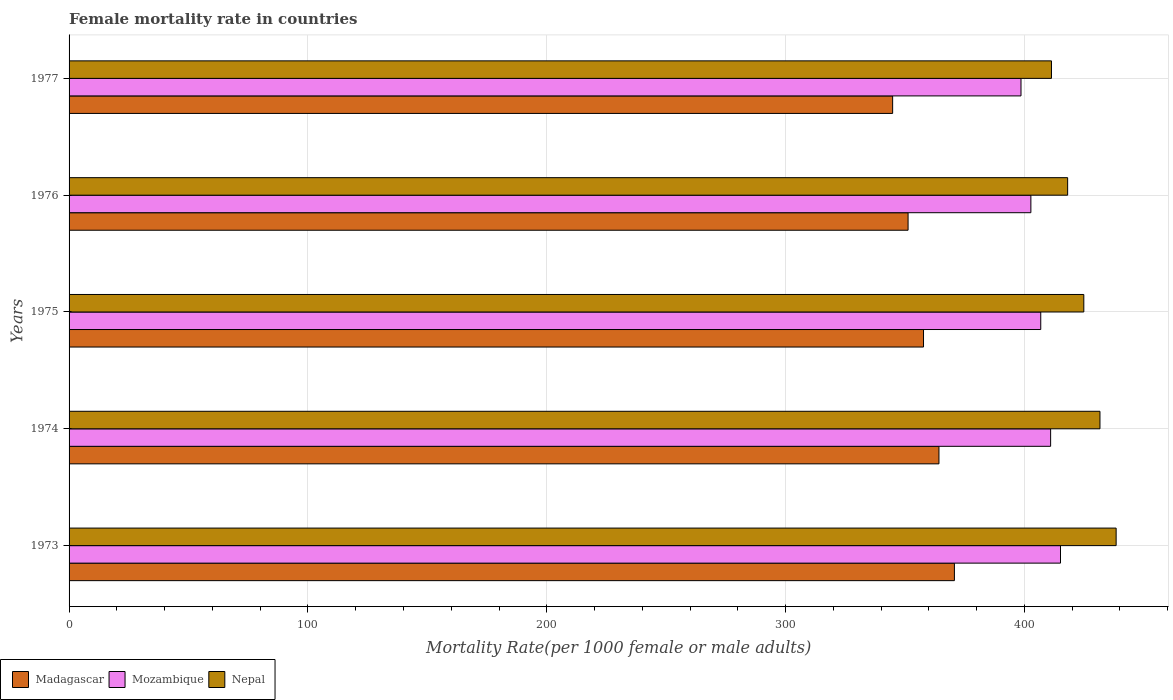How many different coloured bars are there?
Offer a terse response. 3. How many groups of bars are there?
Provide a short and direct response. 5. How many bars are there on the 3rd tick from the bottom?
Give a very brief answer. 3. What is the label of the 3rd group of bars from the top?
Give a very brief answer. 1975. What is the female mortality rate in Nepal in 1975?
Provide a succinct answer. 424.85. Across all years, what is the maximum female mortality rate in Madagascar?
Provide a succinct answer. 370.67. Across all years, what is the minimum female mortality rate in Madagascar?
Give a very brief answer. 344.81. In which year was the female mortality rate in Nepal maximum?
Your response must be concise. 1973. What is the total female mortality rate in Nepal in the graph?
Make the answer very short. 2124.25. What is the difference between the female mortality rate in Mozambique in 1975 and that in 1977?
Ensure brevity in your answer.  8.27. What is the difference between the female mortality rate in Mozambique in 1976 and the female mortality rate in Nepal in 1974?
Your answer should be very brief. -28.93. What is the average female mortality rate in Nepal per year?
Provide a short and direct response. 424.85. In the year 1976, what is the difference between the female mortality rate in Nepal and female mortality rate in Mozambique?
Your answer should be compact. 15.39. What is the ratio of the female mortality rate in Madagascar in 1975 to that in 1977?
Give a very brief answer. 1.04. Is the difference between the female mortality rate in Nepal in 1975 and 1976 greater than the difference between the female mortality rate in Mozambique in 1975 and 1976?
Give a very brief answer. Yes. What is the difference between the highest and the second highest female mortality rate in Nepal?
Offer a very short reply. 6.77. What is the difference between the highest and the lowest female mortality rate in Mozambique?
Your answer should be compact. 16.53. In how many years, is the female mortality rate in Madagascar greater than the average female mortality rate in Madagascar taken over all years?
Keep it short and to the point. 2. What does the 2nd bar from the top in 1977 represents?
Ensure brevity in your answer.  Mozambique. What does the 3rd bar from the bottom in 1973 represents?
Ensure brevity in your answer.  Nepal. Are all the bars in the graph horizontal?
Give a very brief answer. Yes. How many years are there in the graph?
Provide a succinct answer. 5. Does the graph contain any zero values?
Offer a terse response. No. Does the graph contain grids?
Make the answer very short. Yes. How are the legend labels stacked?
Give a very brief answer. Horizontal. What is the title of the graph?
Ensure brevity in your answer.  Female mortality rate in countries. What is the label or title of the X-axis?
Your response must be concise. Mortality Rate(per 1000 female or male adults). What is the label or title of the Y-axis?
Your answer should be compact. Years. What is the Mortality Rate(per 1000 female or male adults) in Madagascar in 1973?
Make the answer very short. 370.67. What is the Mortality Rate(per 1000 female or male adults) of Mozambique in 1973?
Provide a succinct answer. 415.09. What is the Mortality Rate(per 1000 female or male adults) in Nepal in 1973?
Ensure brevity in your answer.  438.39. What is the Mortality Rate(per 1000 female or male adults) of Madagascar in 1974?
Your response must be concise. 364.21. What is the Mortality Rate(per 1000 female or male adults) of Mozambique in 1974?
Your answer should be very brief. 410.96. What is the Mortality Rate(per 1000 female or male adults) of Nepal in 1974?
Offer a terse response. 431.62. What is the Mortality Rate(per 1000 female or male adults) in Madagascar in 1975?
Keep it short and to the point. 357.74. What is the Mortality Rate(per 1000 female or male adults) in Mozambique in 1975?
Offer a very short reply. 406.82. What is the Mortality Rate(per 1000 female or male adults) of Nepal in 1975?
Your answer should be compact. 424.85. What is the Mortality Rate(per 1000 female or male adults) in Madagascar in 1976?
Ensure brevity in your answer.  351.28. What is the Mortality Rate(per 1000 female or male adults) of Mozambique in 1976?
Offer a terse response. 402.69. What is the Mortality Rate(per 1000 female or male adults) in Nepal in 1976?
Your response must be concise. 418.08. What is the Mortality Rate(per 1000 female or male adults) of Madagascar in 1977?
Your answer should be compact. 344.81. What is the Mortality Rate(per 1000 female or male adults) of Mozambique in 1977?
Provide a short and direct response. 398.56. What is the Mortality Rate(per 1000 female or male adults) in Nepal in 1977?
Ensure brevity in your answer.  411.31. Across all years, what is the maximum Mortality Rate(per 1000 female or male adults) of Madagascar?
Your response must be concise. 370.67. Across all years, what is the maximum Mortality Rate(per 1000 female or male adults) of Mozambique?
Give a very brief answer. 415.09. Across all years, what is the maximum Mortality Rate(per 1000 female or male adults) of Nepal?
Give a very brief answer. 438.39. Across all years, what is the minimum Mortality Rate(per 1000 female or male adults) of Madagascar?
Your answer should be compact. 344.81. Across all years, what is the minimum Mortality Rate(per 1000 female or male adults) of Mozambique?
Your response must be concise. 398.56. Across all years, what is the minimum Mortality Rate(per 1000 female or male adults) of Nepal?
Your response must be concise. 411.31. What is the total Mortality Rate(per 1000 female or male adults) in Madagascar in the graph?
Keep it short and to the point. 1788.71. What is the total Mortality Rate(per 1000 female or male adults) in Mozambique in the graph?
Your response must be concise. 2034.12. What is the total Mortality Rate(per 1000 female or male adults) of Nepal in the graph?
Provide a succinct answer. 2124.25. What is the difference between the Mortality Rate(per 1000 female or male adults) of Madagascar in 1973 and that in 1974?
Ensure brevity in your answer.  6.46. What is the difference between the Mortality Rate(per 1000 female or male adults) in Mozambique in 1973 and that in 1974?
Your answer should be very brief. 4.13. What is the difference between the Mortality Rate(per 1000 female or male adults) in Nepal in 1973 and that in 1974?
Your answer should be compact. 6.77. What is the difference between the Mortality Rate(per 1000 female or male adults) in Madagascar in 1973 and that in 1975?
Offer a terse response. 12.93. What is the difference between the Mortality Rate(per 1000 female or male adults) in Mozambique in 1973 and that in 1975?
Keep it short and to the point. 8.27. What is the difference between the Mortality Rate(per 1000 female or male adults) of Nepal in 1973 and that in 1975?
Your answer should be compact. 13.54. What is the difference between the Mortality Rate(per 1000 female or male adults) of Madagascar in 1973 and that in 1976?
Give a very brief answer. 19.39. What is the difference between the Mortality Rate(per 1000 female or male adults) of Mozambique in 1973 and that in 1976?
Ensure brevity in your answer.  12.4. What is the difference between the Mortality Rate(per 1000 female or male adults) of Nepal in 1973 and that in 1976?
Offer a terse response. 20.3. What is the difference between the Mortality Rate(per 1000 female or male adults) in Madagascar in 1973 and that in 1977?
Your answer should be very brief. 25.86. What is the difference between the Mortality Rate(per 1000 female or male adults) of Mozambique in 1973 and that in 1977?
Make the answer very short. 16.53. What is the difference between the Mortality Rate(per 1000 female or male adults) of Nepal in 1973 and that in 1977?
Offer a terse response. 27.07. What is the difference between the Mortality Rate(per 1000 female or male adults) of Madagascar in 1974 and that in 1975?
Keep it short and to the point. 6.46. What is the difference between the Mortality Rate(per 1000 female or male adults) of Mozambique in 1974 and that in 1975?
Provide a succinct answer. 4.13. What is the difference between the Mortality Rate(per 1000 female or male adults) of Nepal in 1974 and that in 1975?
Your answer should be compact. 6.77. What is the difference between the Mortality Rate(per 1000 female or male adults) in Madagascar in 1974 and that in 1976?
Your answer should be compact. 12.93. What is the difference between the Mortality Rate(per 1000 female or male adults) in Mozambique in 1974 and that in 1976?
Make the answer very short. 8.27. What is the difference between the Mortality Rate(per 1000 female or male adults) of Nepal in 1974 and that in 1976?
Offer a very short reply. 13.54. What is the difference between the Mortality Rate(per 1000 female or male adults) in Madagascar in 1974 and that in 1977?
Make the answer very short. 19.39. What is the difference between the Mortality Rate(per 1000 female or male adults) of Mozambique in 1974 and that in 1977?
Your response must be concise. 12.4. What is the difference between the Mortality Rate(per 1000 female or male adults) of Nepal in 1974 and that in 1977?
Your answer should be compact. 20.3. What is the difference between the Mortality Rate(per 1000 female or male adults) of Madagascar in 1975 and that in 1976?
Provide a short and direct response. 6.46. What is the difference between the Mortality Rate(per 1000 female or male adults) in Mozambique in 1975 and that in 1976?
Make the answer very short. 4.13. What is the difference between the Mortality Rate(per 1000 female or male adults) in Nepal in 1975 and that in 1976?
Your response must be concise. 6.77. What is the difference between the Mortality Rate(per 1000 female or male adults) in Madagascar in 1975 and that in 1977?
Ensure brevity in your answer.  12.93. What is the difference between the Mortality Rate(per 1000 female or male adults) of Mozambique in 1975 and that in 1977?
Keep it short and to the point. 8.27. What is the difference between the Mortality Rate(per 1000 female or male adults) of Nepal in 1975 and that in 1977?
Keep it short and to the point. 13.54. What is the difference between the Mortality Rate(per 1000 female or male adults) in Madagascar in 1976 and that in 1977?
Give a very brief answer. 6.46. What is the difference between the Mortality Rate(per 1000 female or male adults) in Mozambique in 1976 and that in 1977?
Ensure brevity in your answer.  4.13. What is the difference between the Mortality Rate(per 1000 female or male adults) of Nepal in 1976 and that in 1977?
Your answer should be compact. 6.77. What is the difference between the Mortality Rate(per 1000 female or male adults) of Madagascar in 1973 and the Mortality Rate(per 1000 female or male adults) of Mozambique in 1974?
Your answer should be compact. -40.29. What is the difference between the Mortality Rate(per 1000 female or male adults) of Madagascar in 1973 and the Mortality Rate(per 1000 female or male adults) of Nepal in 1974?
Keep it short and to the point. -60.95. What is the difference between the Mortality Rate(per 1000 female or male adults) in Mozambique in 1973 and the Mortality Rate(per 1000 female or male adults) in Nepal in 1974?
Offer a terse response. -16.53. What is the difference between the Mortality Rate(per 1000 female or male adults) of Madagascar in 1973 and the Mortality Rate(per 1000 female or male adults) of Mozambique in 1975?
Ensure brevity in your answer.  -36.15. What is the difference between the Mortality Rate(per 1000 female or male adults) in Madagascar in 1973 and the Mortality Rate(per 1000 female or male adults) in Nepal in 1975?
Your response must be concise. -54.18. What is the difference between the Mortality Rate(per 1000 female or male adults) in Mozambique in 1973 and the Mortality Rate(per 1000 female or male adults) in Nepal in 1975?
Your response must be concise. -9.76. What is the difference between the Mortality Rate(per 1000 female or male adults) of Madagascar in 1973 and the Mortality Rate(per 1000 female or male adults) of Mozambique in 1976?
Provide a succinct answer. -32.02. What is the difference between the Mortality Rate(per 1000 female or male adults) of Madagascar in 1973 and the Mortality Rate(per 1000 female or male adults) of Nepal in 1976?
Keep it short and to the point. -47.41. What is the difference between the Mortality Rate(per 1000 female or male adults) in Mozambique in 1973 and the Mortality Rate(per 1000 female or male adults) in Nepal in 1976?
Provide a succinct answer. -2.99. What is the difference between the Mortality Rate(per 1000 female or male adults) in Madagascar in 1973 and the Mortality Rate(per 1000 female or male adults) in Mozambique in 1977?
Offer a very short reply. -27.89. What is the difference between the Mortality Rate(per 1000 female or male adults) in Madagascar in 1973 and the Mortality Rate(per 1000 female or male adults) in Nepal in 1977?
Your response must be concise. -40.64. What is the difference between the Mortality Rate(per 1000 female or male adults) in Mozambique in 1973 and the Mortality Rate(per 1000 female or male adults) in Nepal in 1977?
Offer a terse response. 3.78. What is the difference between the Mortality Rate(per 1000 female or male adults) of Madagascar in 1974 and the Mortality Rate(per 1000 female or male adults) of Mozambique in 1975?
Your response must be concise. -42.62. What is the difference between the Mortality Rate(per 1000 female or male adults) in Madagascar in 1974 and the Mortality Rate(per 1000 female or male adults) in Nepal in 1975?
Offer a very short reply. -60.65. What is the difference between the Mortality Rate(per 1000 female or male adults) in Mozambique in 1974 and the Mortality Rate(per 1000 female or male adults) in Nepal in 1975?
Your answer should be very brief. -13.89. What is the difference between the Mortality Rate(per 1000 female or male adults) in Madagascar in 1974 and the Mortality Rate(per 1000 female or male adults) in Mozambique in 1976?
Keep it short and to the point. -38.48. What is the difference between the Mortality Rate(per 1000 female or male adults) of Madagascar in 1974 and the Mortality Rate(per 1000 female or male adults) of Nepal in 1976?
Your answer should be very brief. -53.88. What is the difference between the Mortality Rate(per 1000 female or male adults) in Mozambique in 1974 and the Mortality Rate(per 1000 female or male adults) in Nepal in 1976?
Offer a terse response. -7.12. What is the difference between the Mortality Rate(per 1000 female or male adults) of Madagascar in 1974 and the Mortality Rate(per 1000 female or male adults) of Mozambique in 1977?
Offer a very short reply. -34.35. What is the difference between the Mortality Rate(per 1000 female or male adults) of Madagascar in 1974 and the Mortality Rate(per 1000 female or male adults) of Nepal in 1977?
Offer a terse response. -47.11. What is the difference between the Mortality Rate(per 1000 female or male adults) in Mozambique in 1974 and the Mortality Rate(per 1000 female or male adults) in Nepal in 1977?
Ensure brevity in your answer.  -0.36. What is the difference between the Mortality Rate(per 1000 female or male adults) of Madagascar in 1975 and the Mortality Rate(per 1000 female or male adults) of Mozambique in 1976?
Make the answer very short. -44.95. What is the difference between the Mortality Rate(per 1000 female or male adults) in Madagascar in 1975 and the Mortality Rate(per 1000 female or male adults) in Nepal in 1976?
Ensure brevity in your answer.  -60.34. What is the difference between the Mortality Rate(per 1000 female or male adults) of Mozambique in 1975 and the Mortality Rate(per 1000 female or male adults) of Nepal in 1976?
Offer a terse response. -11.26. What is the difference between the Mortality Rate(per 1000 female or male adults) in Madagascar in 1975 and the Mortality Rate(per 1000 female or male adults) in Mozambique in 1977?
Keep it short and to the point. -40.81. What is the difference between the Mortality Rate(per 1000 female or male adults) in Madagascar in 1975 and the Mortality Rate(per 1000 female or male adults) in Nepal in 1977?
Your answer should be very brief. -53.57. What is the difference between the Mortality Rate(per 1000 female or male adults) of Mozambique in 1975 and the Mortality Rate(per 1000 female or male adults) of Nepal in 1977?
Your answer should be very brief. -4.49. What is the difference between the Mortality Rate(per 1000 female or male adults) in Madagascar in 1976 and the Mortality Rate(per 1000 female or male adults) in Mozambique in 1977?
Make the answer very short. -47.28. What is the difference between the Mortality Rate(per 1000 female or male adults) of Madagascar in 1976 and the Mortality Rate(per 1000 female or male adults) of Nepal in 1977?
Make the answer very short. -60.04. What is the difference between the Mortality Rate(per 1000 female or male adults) of Mozambique in 1976 and the Mortality Rate(per 1000 female or male adults) of Nepal in 1977?
Keep it short and to the point. -8.62. What is the average Mortality Rate(per 1000 female or male adults) of Madagascar per year?
Make the answer very short. 357.74. What is the average Mortality Rate(per 1000 female or male adults) of Mozambique per year?
Make the answer very short. 406.82. What is the average Mortality Rate(per 1000 female or male adults) of Nepal per year?
Your answer should be very brief. 424.85. In the year 1973, what is the difference between the Mortality Rate(per 1000 female or male adults) of Madagascar and Mortality Rate(per 1000 female or male adults) of Mozambique?
Your answer should be very brief. -44.42. In the year 1973, what is the difference between the Mortality Rate(per 1000 female or male adults) in Madagascar and Mortality Rate(per 1000 female or male adults) in Nepal?
Offer a terse response. -67.72. In the year 1973, what is the difference between the Mortality Rate(per 1000 female or male adults) in Mozambique and Mortality Rate(per 1000 female or male adults) in Nepal?
Your answer should be compact. -23.3. In the year 1974, what is the difference between the Mortality Rate(per 1000 female or male adults) in Madagascar and Mortality Rate(per 1000 female or male adults) in Mozambique?
Provide a succinct answer. -46.75. In the year 1974, what is the difference between the Mortality Rate(per 1000 female or male adults) of Madagascar and Mortality Rate(per 1000 female or male adults) of Nepal?
Keep it short and to the point. -67.41. In the year 1974, what is the difference between the Mortality Rate(per 1000 female or male adults) of Mozambique and Mortality Rate(per 1000 female or male adults) of Nepal?
Give a very brief answer. -20.66. In the year 1975, what is the difference between the Mortality Rate(per 1000 female or male adults) in Madagascar and Mortality Rate(per 1000 female or male adults) in Mozambique?
Your answer should be very brief. -49.08. In the year 1975, what is the difference between the Mortality Rate(per 1000 female or male adults) in Madagascar and Mortality Rate(per 1000 female or male adults) in Nepal?
Provide a succinct answer. -67.11. In the year 1975, what is the difference between the Mortality Rate(per 1000 female or male adults) of Mozambique and Mortality Rate(per 1000 female or male adults) of Nepal?
Your answer should be compact. -18.03. In the year 1976, what is the difference between the Mortality Rate(per 1000 female or male adults) in Madagascar and Mortality Rate(per 1000 female or male adults) in Mozambique?
Your answer should be very brief. -51.41. In the year 1976, what is the difference between the Mortality Rate(per 1000 female or male adults) in Madagascar and Mortality Rate(per 1000 female or male adults) in Nepal?
Offer a very short reply. -66.8. In the year 1976, what is the difference between the Mortality Rate(per 1000 female or male adults) in Mozambique and Mortality Rate(per 1000 female or male adults) in Nepal?
Provide a succinct answer. -15.39. In the year 1977, what is the difference between the Mortality Rate(per 1000 female or male adults) in Madagascar and Mortality Rate(per 1000 female or male adults) in Mozambique?
Provide a succinct answer. -53.74. In the year 1977, what is the difference between the Mortality Rate(per 1000 female or male adults) in Madagascar and Mortality Rate(per 1000 female or male adults) in Nepal?
Ensure brevity in your answer.  -66.5. In the year 1977, what is the difference between the Mortality Rate(per 1000 female or male adults) of Mozambique and Mortality Rate(per 1000 female or male adults) of Nepal?
Offer a terse response. -12.76. What is the ratio of the Mortality Rate(per 1000 female or male adults) in Madagascar in 1973 to that in 1974?
Make the answer very short. 1.02. What is the ratio of the Mortality Rate(per 1000 female or male adults) in Nepal in 1973 to that in 1974?
Keep it short and to the point. 1.02. What is the ratio of the Mortality Rate(per 1000 female or male adults) of Madagascar in 1973 to that in 1975?
Offer a very short reply. 1.04. What is the ratio of the Mortality Rate(per 1000 female or male adults) in Mozambique in 1973 to that in 1975?
Provide a succinct answer. 1.02. What is the ratio of the Mortality Rate(per 1000 female or male adults) in Nepal in 1973 to that in 1975?
Ensure brevity in your answer.  1.03. What is the ratio of the Mortality Rate(per 1000 female or male adults) in Madagascar in 1973 to that in 1976?
Provide a succinct answer. 1.06. What is the ratio of the Mortality Rate(per 1000 female or male adults) of Mozambique in 1973 to that in 1976?
Keep it short and to the point. 1.03. What is the ratio of the Mortality Rate(per 1000 female or male adults) of Nepal in 1973 to that in 1976?
Offer a terse response. 1.05. What is the ratio of the Mortality Rate(per 1000 female or male adults) in Madagascar in 1973 to that in 1977?
Provide a short and direct response. 1.07. What is the ratio of the Mortality Rate(per 1000 female or male adults) of Mozambique in 1973 to that in 1977?
Keep it short and to the point. 1.04. What is the ratio of the Mortality Rate(per 1000 female or male adults) in Nepal in 1973 to that in 1977?
Keep it short and to the point. 1.07. What is the ratio of the Mortality Rate(per 1000 female or male adults) of Madagascar in 1974 to that in 1975?
Your answer should be very brief. 1.02. What is the ratio of the Mortality Rate(per 1000 female or male adults) in Mozambique in 1974 to that in 1975?
Make the answer very short. 1.01. What is the ratio of the Mortality Rate(per 1000 female or male adults) of Nepal in 1974 to that in 1975?
Your response must be concise. 1.02. What is the ratio of the Mortality Rate(per 1000 female or male adults) in Madagascar in 1974 to that in 1976?
Your answer should be compact. 1.04. What is the ratio of the Mortality Rate(per 1000 female or male adults) of Mozambique in 1974 to that in 1976?
Your response must be concise. 1.02. What is the ratio of the Mortality Rate(per 1000 female or male adults) in Nepal in 1974 to that in 1976?
Provide a short and direct response. 1.03. What is the ratio of the Mortality Rate(per 1000 female or male adults) in Madagascar in 1974 to that in 1977?
Keep it short and to the point. 1.06. What is the ratio of the Mortality Rate(per 1000 female or male adults) of Mozambique in 1974 to that in 1977?
Your response must be concise. 1.03. What is the ratio of the Mortality Rate(per 1000 female or male adults) of Nepal in 1974 to that in 1977?
Offer a terse response. 1.05. What is the ratio of the Mortality Rate(per 1000 female or male adults) of Madagascar in 1975 to that in 1976?
Give a very brief answer. 1.02. What is the ratio of the Mortality Rate(per 1000 female or male adults) in Mozambique in 1975 to that in 1976?
Make the answer very short. 1.01. What is the ratio of the Mortality Rate(per 1000 female or male adults) of Nepal in 1975 to that in 1976?
Keep it short and to the point. 1.02. What is the ratio of the Mortality Rate(per 1000 female or male adults) in Madagascar in 1975 to that in 1977?
Ensure brevity in your answer.  1.04. What is the ratio of the Mortality Rate(per 1000 female or male adults) in Mozambique in 1975 to that in 1977?
Your answer should be compact. 1.02. What is the ratio of the Mortality Rate(per 1000 female or male adults) of Nepal in 1975 to that in 1977?
Your answer should be compact. 1.03. What is the ratio of the Mortality Rate(per 1000 female or male adults) of Madagascar in 1976 to that in 1977?
Give a very brief answer. 1.02. What is the ratio of the Mortality Rate(per 1000 female or male adults) in Mozambique in 1976 to that in 1977?
Make the answer very short. 1.01. What is the ratio of the Mortality Rate(per 1000 female or male adults) of Nepal in 1976 to that in 1977?
Offer a terse response. 1.02. What is the difference between the highest and the second highest Mortality Rate(per 1000 female or male adults) of Madagascar?
Make the answer very short. 6.46. What is the difference between the highest and the second highest Mortality Rate(per 1000 female or male adults) in Mozambique?
Offer a very short reply. 4.13. What is the difference between the highest and the second highest Mortality Rate(per 1000 female or male adults) of Nepal?
Your response must be concise. 6.77. What is the difference between the highest and the lowest Mortality Rate(per 1000 female or male adults) in Madagascar?
Your response must be concise. 25.86. What is the difference between the highest and the lowest Mortality Rate(per 1000 female or male adults) in Mozambique?
Offer a terse response. 16.53. What is the difference between the highest and the lowest Mortality Rate(per 1000 female or male adults) in Nepal?
Your response must be concise. 27.07. 